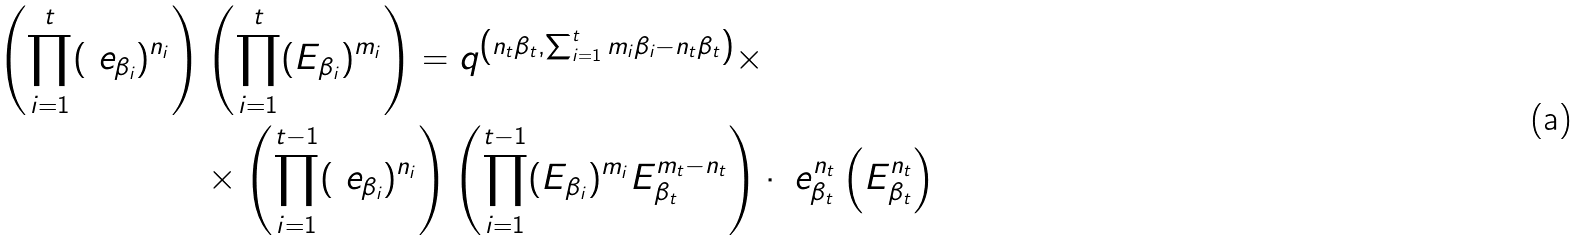Convert formula to latex. <formula><loc_0><loc_0><loc_500><loc_500>\left ( \prod _ { i = 1 } ^ { t } ( \ e _ { \beta _ { i } } ) ^ { n _ { i } } \right ) & \left ( \prod _ { i = 1 } ^ { t } ( E _ { \beta _ { i } } ) ^ { m _ { i } } \right ) = q ^ { \left ( n _ { t } \beta _ { t } , \sum _ { i = 1 } ^ { t } m _ { i } \beta _ { i } - n _ { t } \beta _ { t } \right ) } \times \\ & \times \left ( \prod _ { i = 1 } ^ { t - 1 } ( \ e _ { \beta _ { i } } ) ^ { n _ { i } } \right ) \left ( \prod _ { i = 1 } ^ { t - 1 } ( E _ { \beta _ { i } } ) ^ { m _ { i } } E _ { \beta _ { t } } ^ { m _ { t } - n _ { t } } \right ) \cdot \ e _ { \beta _ { t } } ^ { n _ { t } } \left ( E _ { \beta _ { t } } ^ { n _ { t } } \right )</formula> 